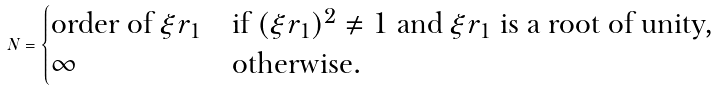<formula> <loc_0><loc_0><loc_500><loc_500>N = \begin{cases} \text {order of $\xi r_{1}$} & \text {if $(\xi r_{1})^{2}\neq 1$ and $\xi r_{1}$ is a root of unity,} \\ \infty & \text {otherwise.} \end{cases}</formula> 